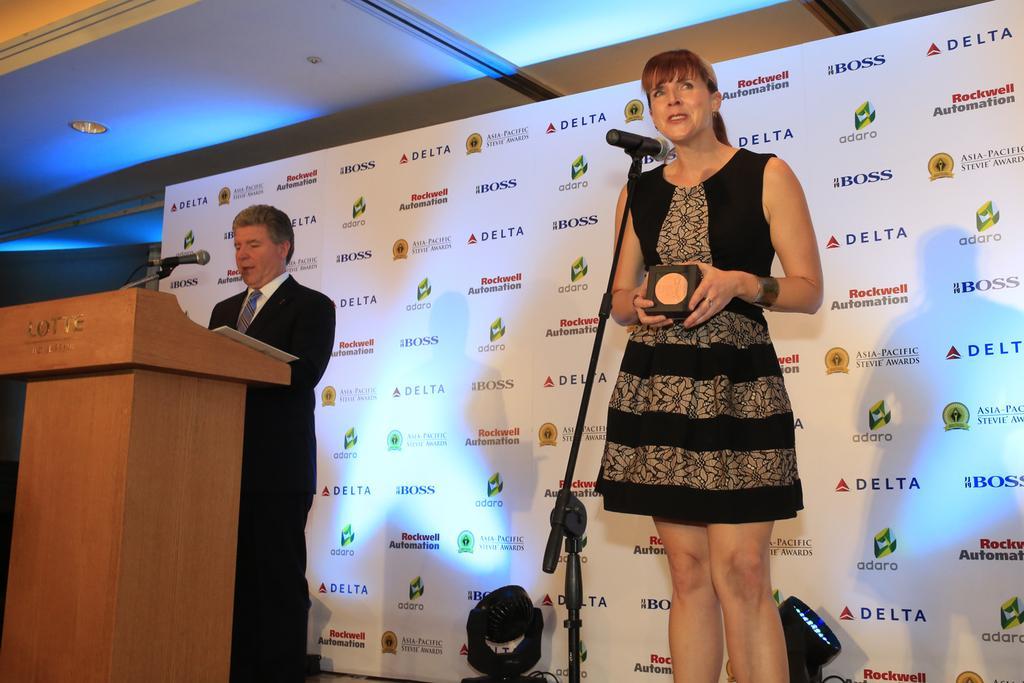Please provide a concise description of this image. In this picture we can observe two members. One of them is a man wearing a coat. He is standing in front of a podium and the other is a woman wearing black color dress and standing in front of a mic and a stand. Behind them there is a poster which is in white color. We can observe blue color light in the background. 